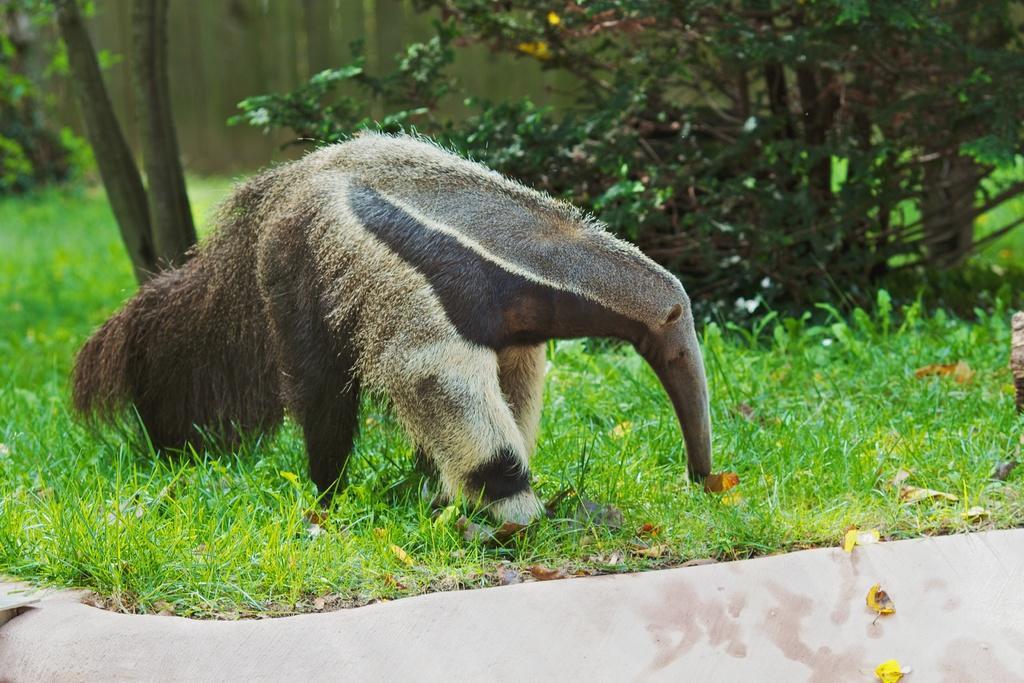Can you describe this image briefly? In the image there is an animal grazing the grass and behind the animal there are few trees and grass. 